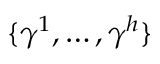Convert formula to latex. <formula><loc_0><loc_0><loc_500><loc_500>\{ \gamma ^ { 1 } , \dots , \gamma ^ { h } \}</formula> 